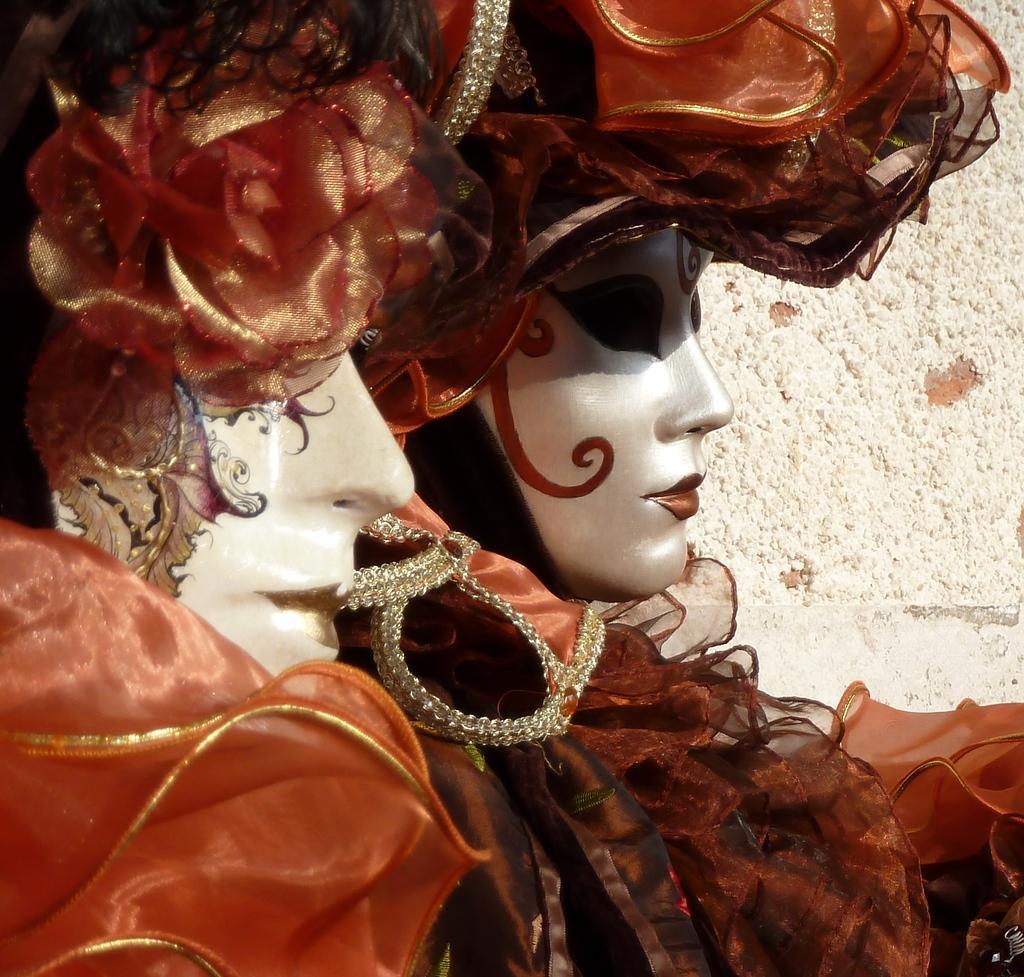Can you describe this image briefly? On the left side, there are two persons in orange color dresses, having makeup. In the background, there is a white color surface. 